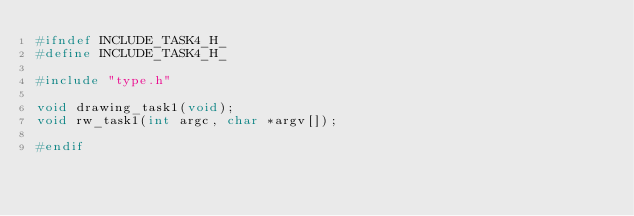Convert code to text. <code><loc_0><loc_0><loc_500><loc_500><_C_>#ifndef INCLUDE_TASK4_H_
#define INCLUDE_TASK4_H_

#include "type.h"

void drawing_task1(void);
void rw_task1(int argc, char *argv[]);

#endif
</code> 